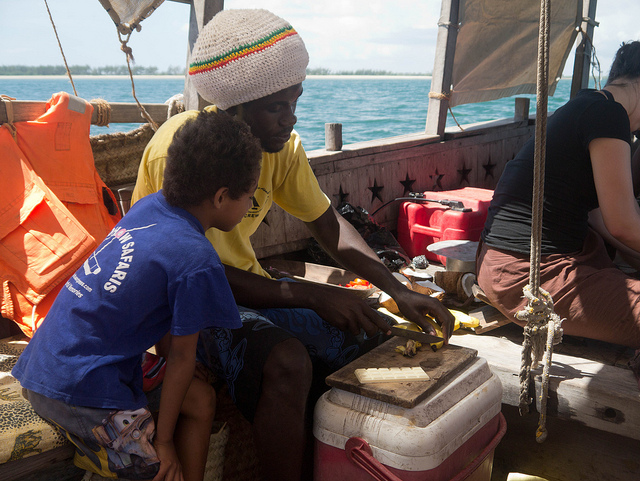<image>What is the man cutting? It is unknown what the man is cutting. It could be food, bananas, fish, or meat. What is the man cutting? I don't know what the man is cutting. It can be food, bananas, banana, bate, fish, or meat. 